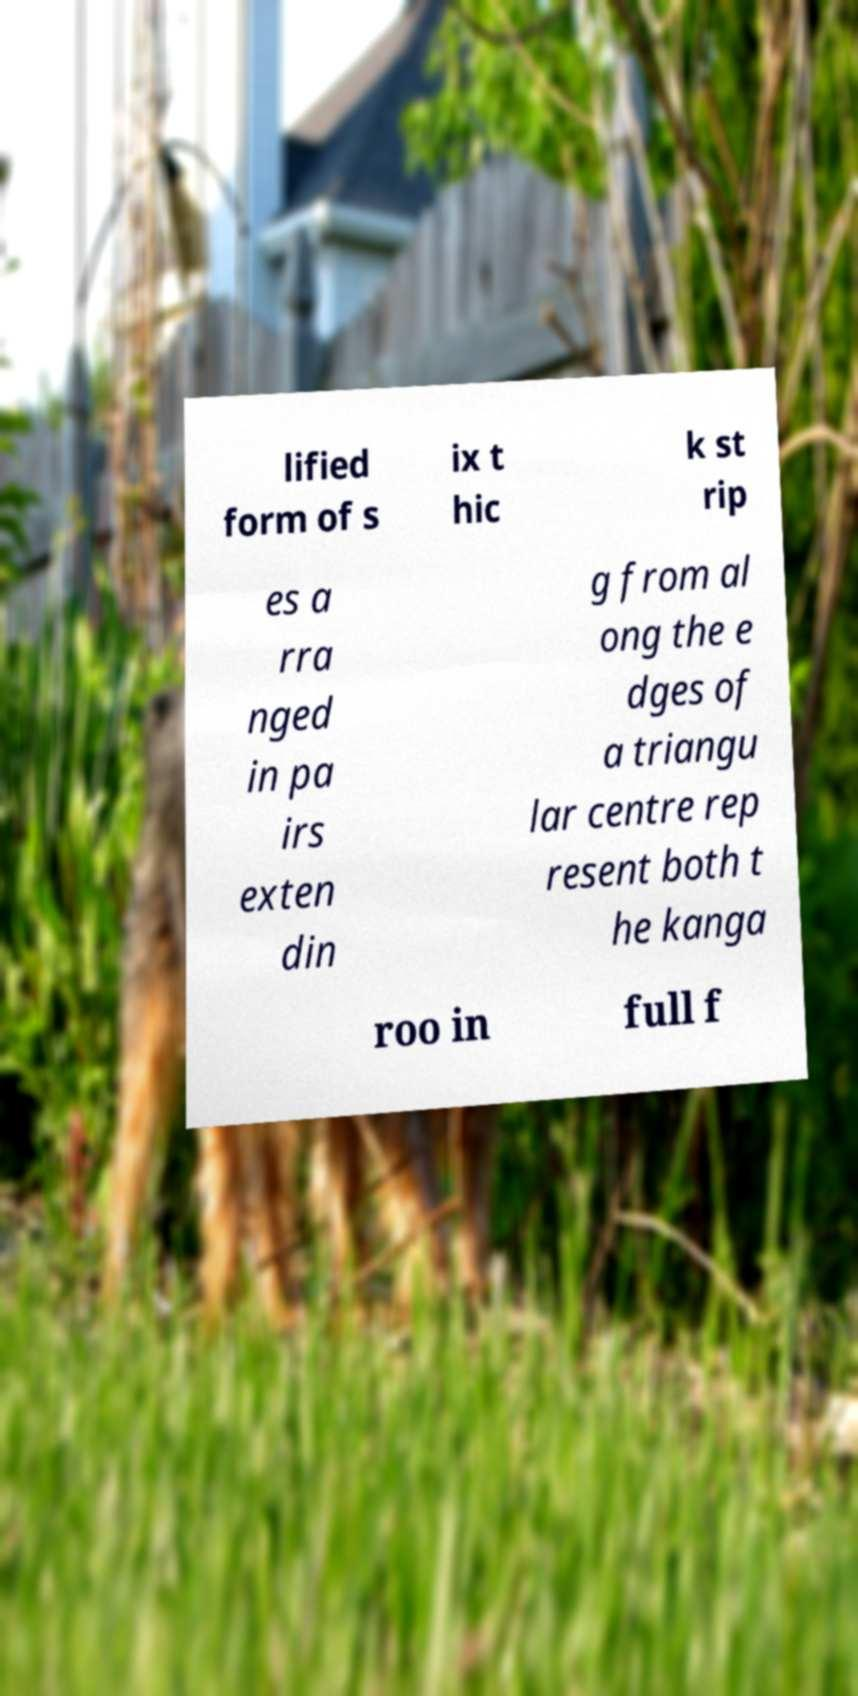Please identify and transcribe the text found in this image. lified form of s ix t hic k st rip es a rra nged in pa irs exten din g from al ong the e dges of a triangu lar centre rep resent both t he kanga roo in full f 